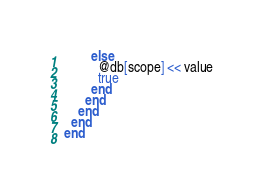<code> <loc_0><loc_0><loc_500><loc_500><_Ruby_>        else
          @db[scope] << value
          true
        end
      end
    end
  end
end
</code> 